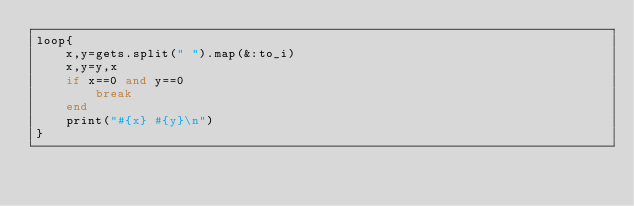<code> <loc_0><loc_0><loc_500><loc_500><_Ruby_>loop{
	x,y=gets.split(" ").map(&:to_i)
	x,y=y,x
	if x==0 and y==0
		break
	end
	print("#{x} #{y}\n")
}</code> 